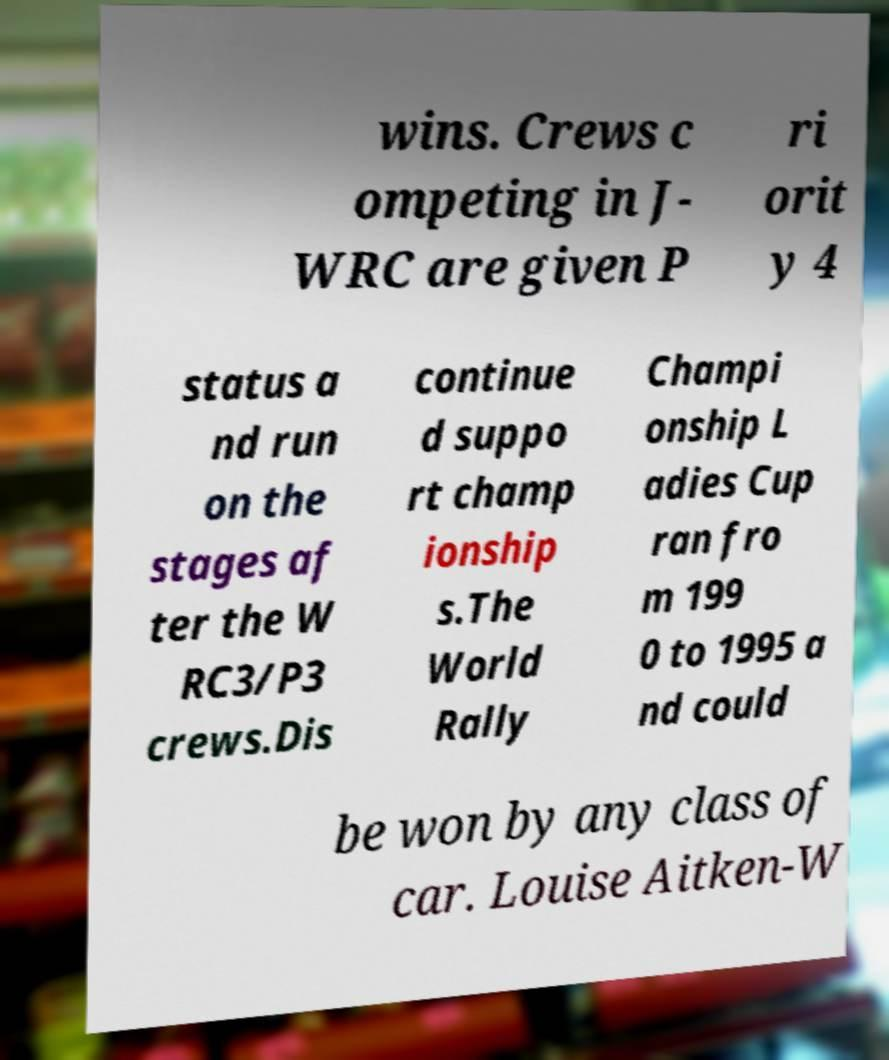Could you assist in decoding the text presented in this image and type it out clearly? wins. Crews c ompeting in J- WRC are given P ri orit y 4 status a nd run on the stages af ter the W RC3/P3 crews.Dis continue d suppo rt champ ionship s.The World Rally Champi onship L adies Cup ran fro m 199 0 to 1995 a nd could be won by any class of car. Louise Aitken-W 